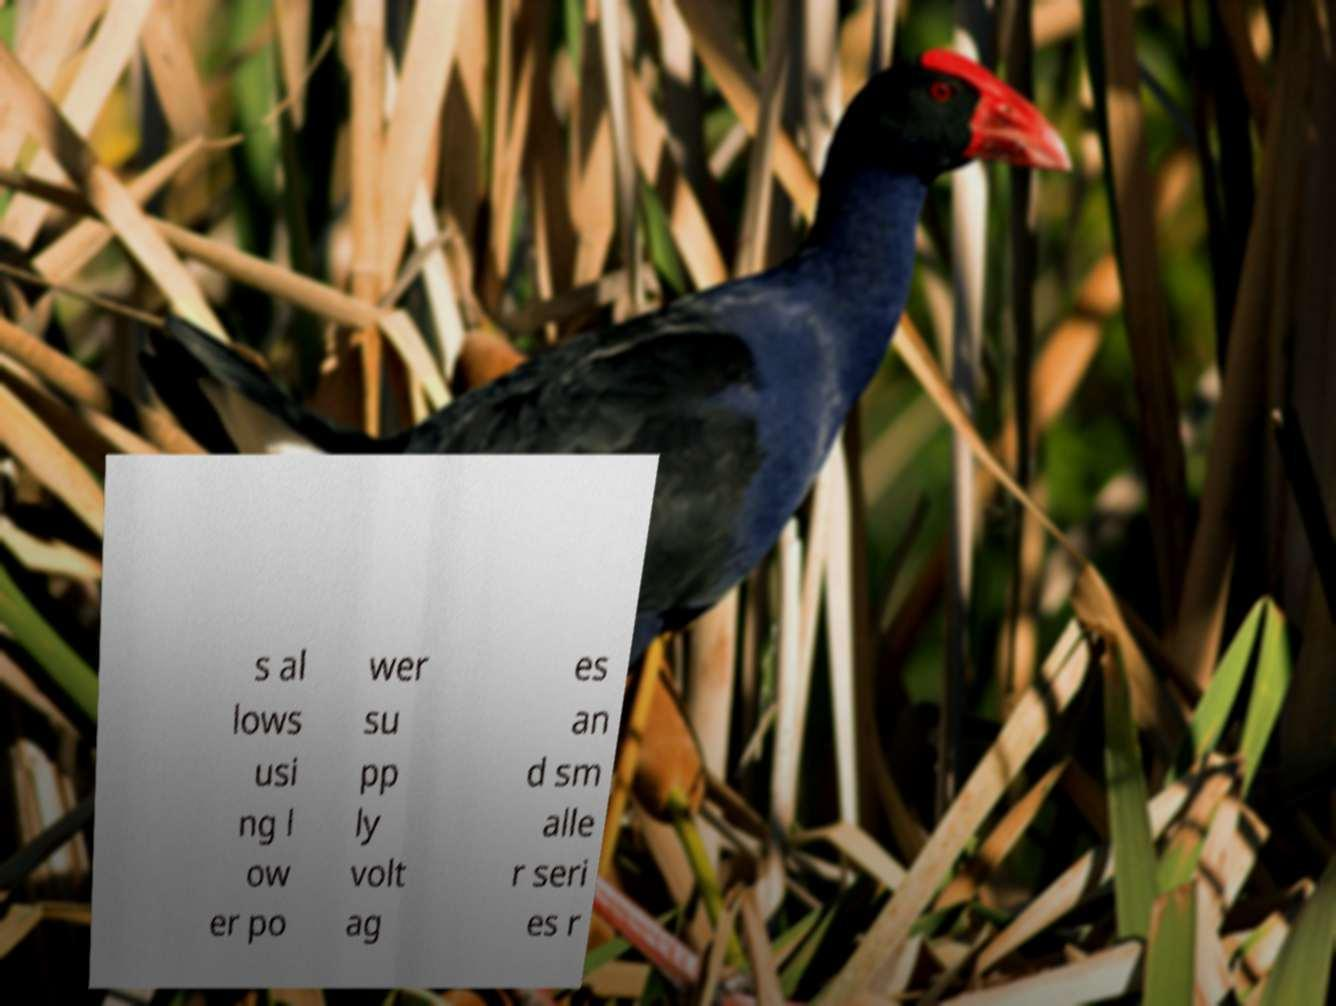For documentation purposes, I need the text within this image transcribed. Could you provide that? s al lows usi ng l ow er po wer su pp ly volt ag es an d sm alle r seri es r 